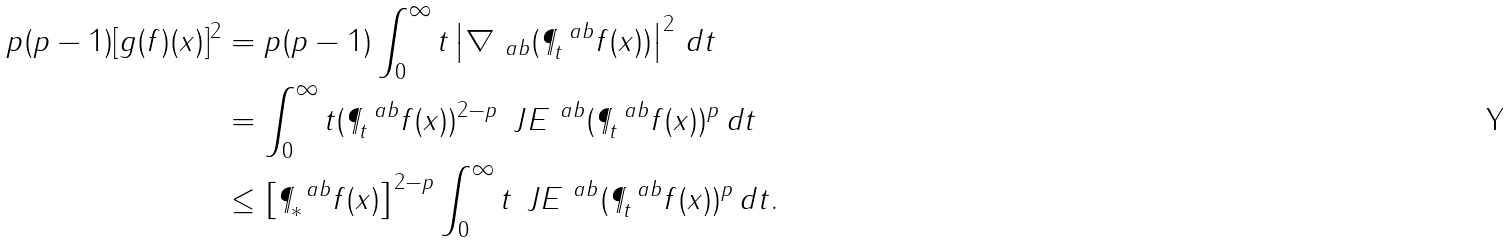<formula> <loc_0><loc_0><loc_500><loc_500>p ( p - 1 ) [ g ( f ) ( x ) ] ^ { 2 } & = p ( p - 1 ) \int _ { 0 } ^ { \infty } t \left | \nabla _ { \ a b } ( \P ^ { \ a b } _ { t } f ( x ) ) \right | ^ { 2 } \, d t \\ & = \int _ { 0 } ^ { \infty } t ( \P ^ { \ a b } _ { t } f ( x ) ) ^ { 2 - p } \, \ J E ^ { \ a b } ( \P ^ { \ a b } _ { t } f ( x ) ) ^ { p } \, d t \\ & \leq \left [ \P ^ { \ a b } _ { * } f ( x ) \right ] ^ { 2 - p } \int _ { 0 } ^ { \infty } t \, \ J E ^ { \ a b } ( \P ^ { \ a b } _ { t } f ( x ) ) ^ { p } \, d t .</formula> 